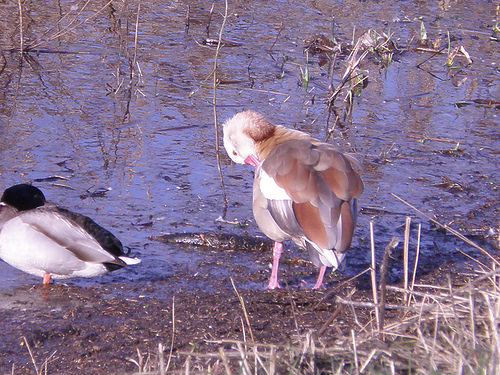<image>
Is the dock under the water? No. The dock is not positioned under the water. The vertical relationship between these objects is different. Is the duck in front of the pond? Yes. The duck is positioned in front of the pond, appearing closer to the camera viewpoint. 